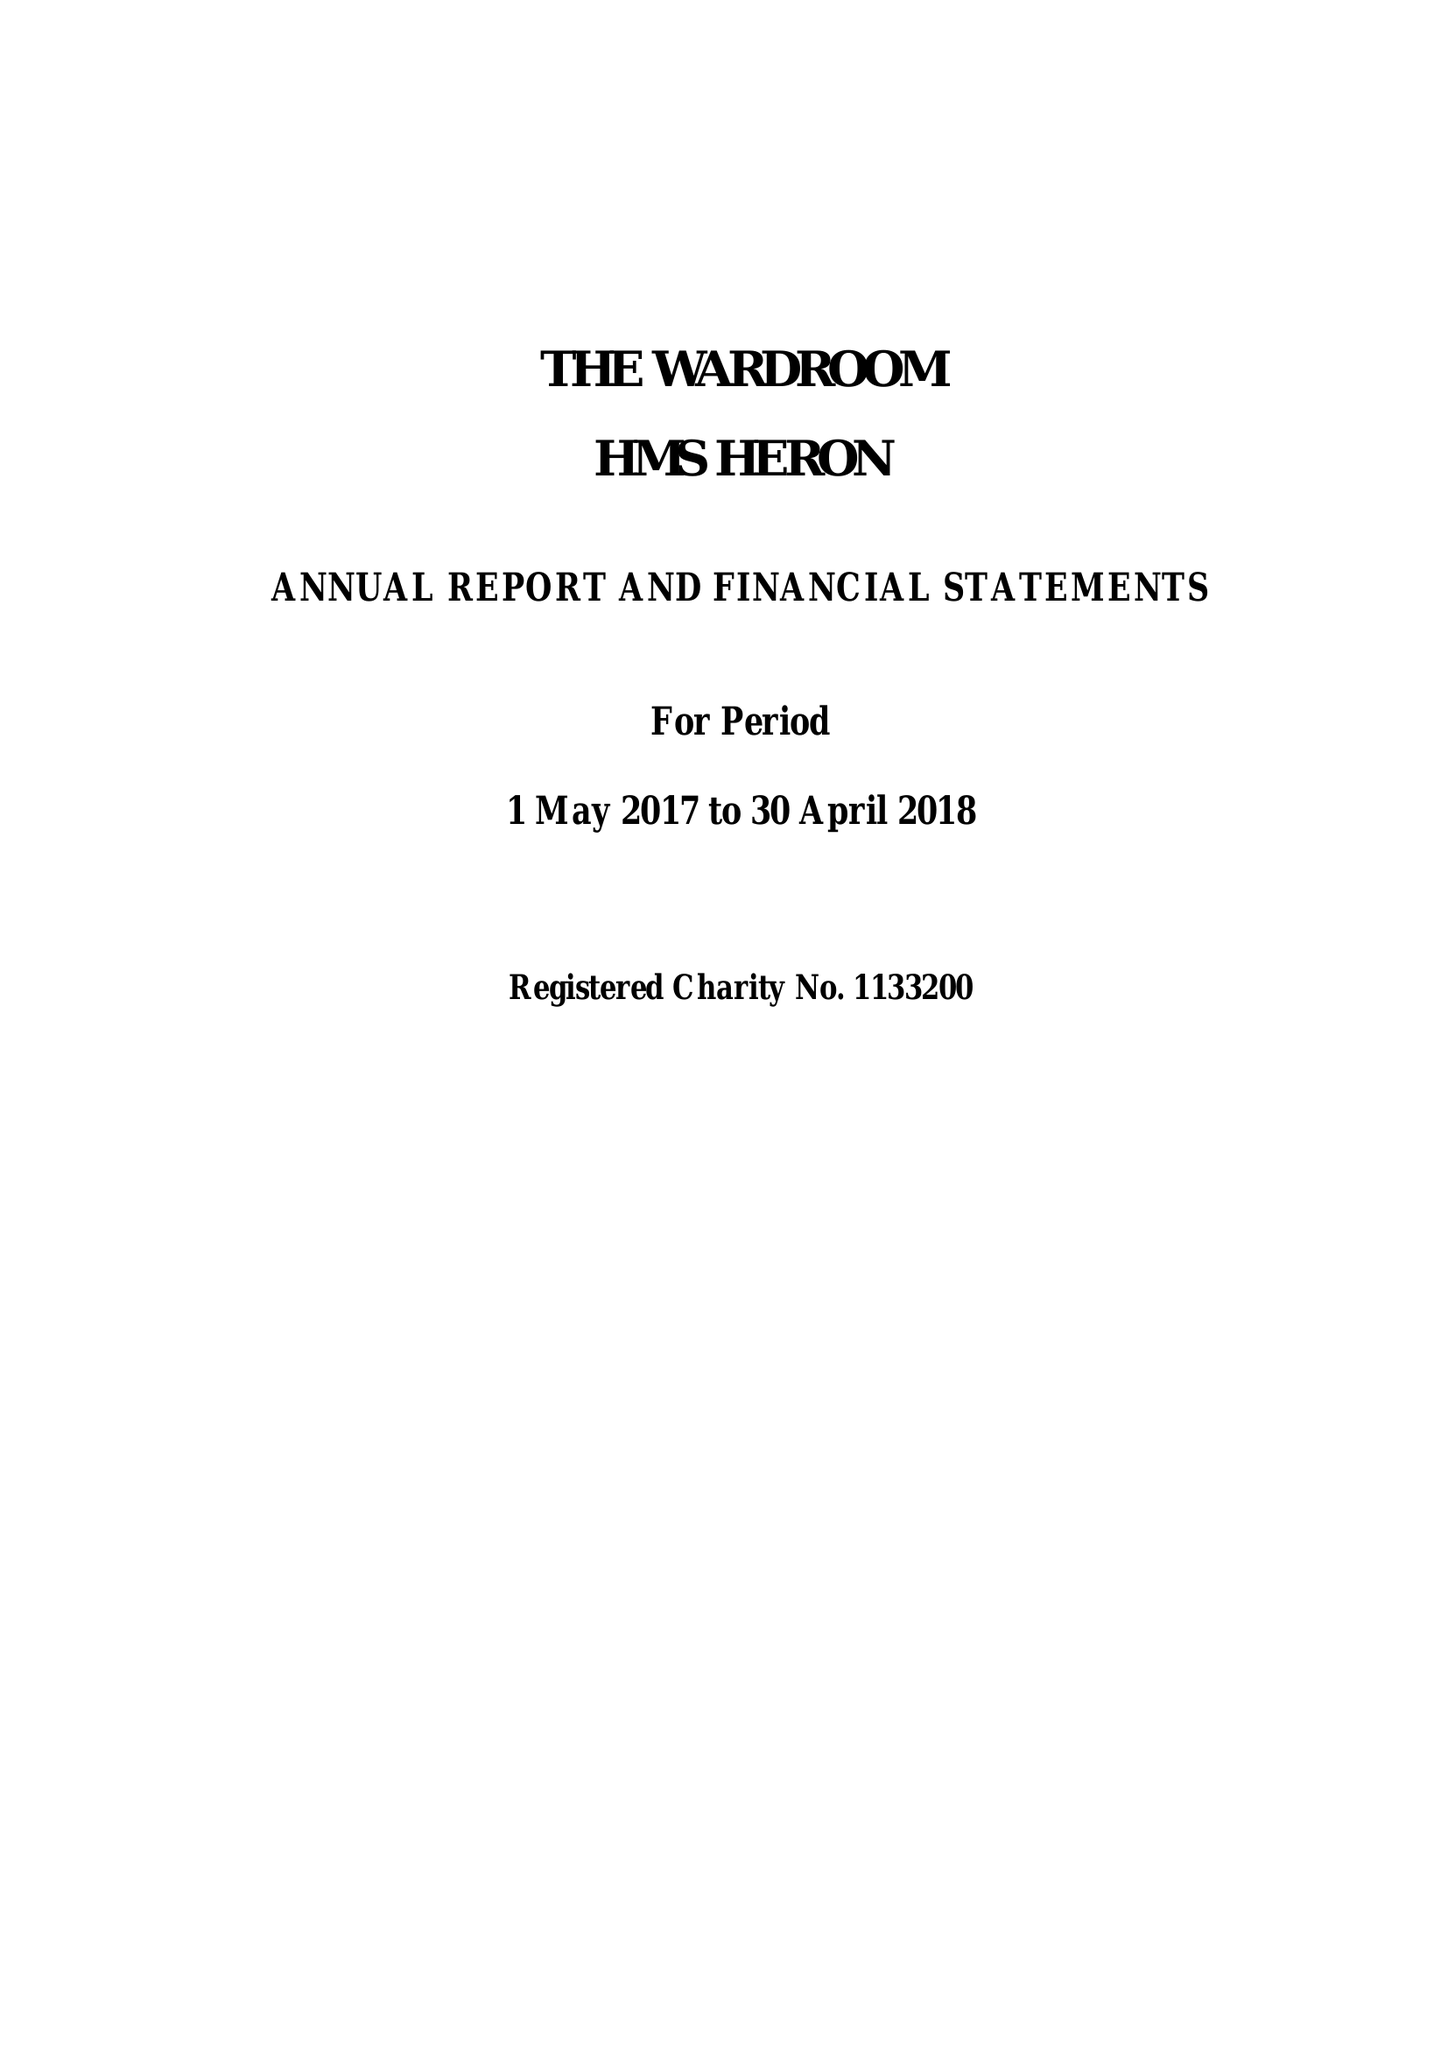What is the value for the charity_name?
Answer the question using a single word or phrase. Wardroom Mess Hms Heron 